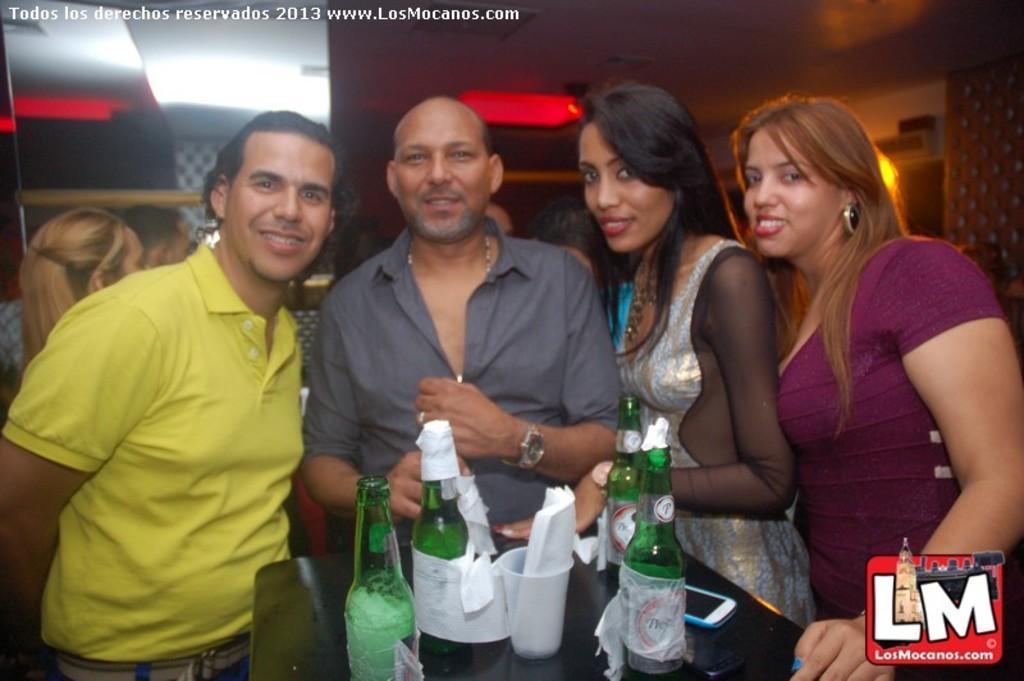Could you give a brief overview of what you see in this image? These four persons are standing and giving stills. In-front of them there is a table, on this table there are bottles, cup, papers and mobile. 